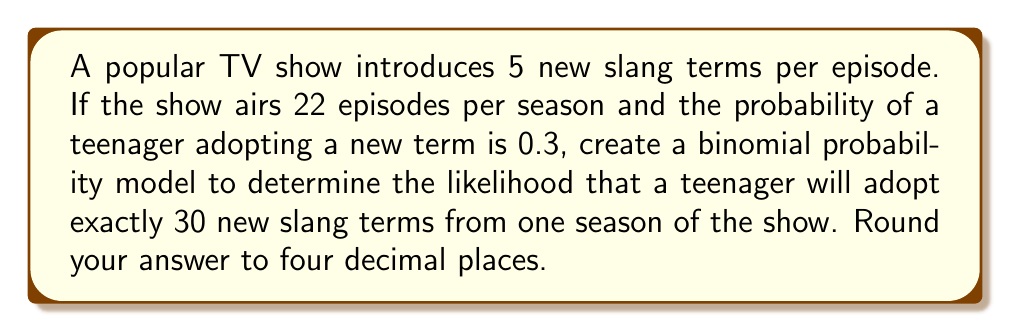Solve this math problem. To solve this problem, we'll use the binomial probability distribution model. Let's break it down step-by-step:

1. Identify the parameters:
   - $n$ = total number of trials (new slang terms introduced)
   - $p$ = probability of success (adopting a term)
   - $k$ = number of successes we're interested in

2. Calculate $n$:
   $n = 5 \text{ terms/episode} \times 22 \text{ episodes/season} = 110 \text{ terms/season}$

3. We're given:
   $p = 0.3$
   $k = 30$

4. The binomial probability formula is:
   $$P(X = k) = \binom{n}{k} p^k (1-p)^{n-k}$$

5. Calculate $\binom{n}{k}$:
   $$\binom{110}{30} = \frac{110!}{30!(110-30)!} = \frac{110!}{30!80!}$$

6. Substitute into the formula:
   $$P(X = 30) = \binom{110}{30} (0.3)^{30} (1-0.3)^{110-30}$$
   $$= \binom{110}{30} (0.3)^{30} (0.7)^{80}$$

7. Calculate using a calculator or computer:
   $$P(X = 30) \approx 0.0815$$

8. Round to four decimal places:
   $$P(X = 30) \approx 0.0815$$
Answer: 0.0815 